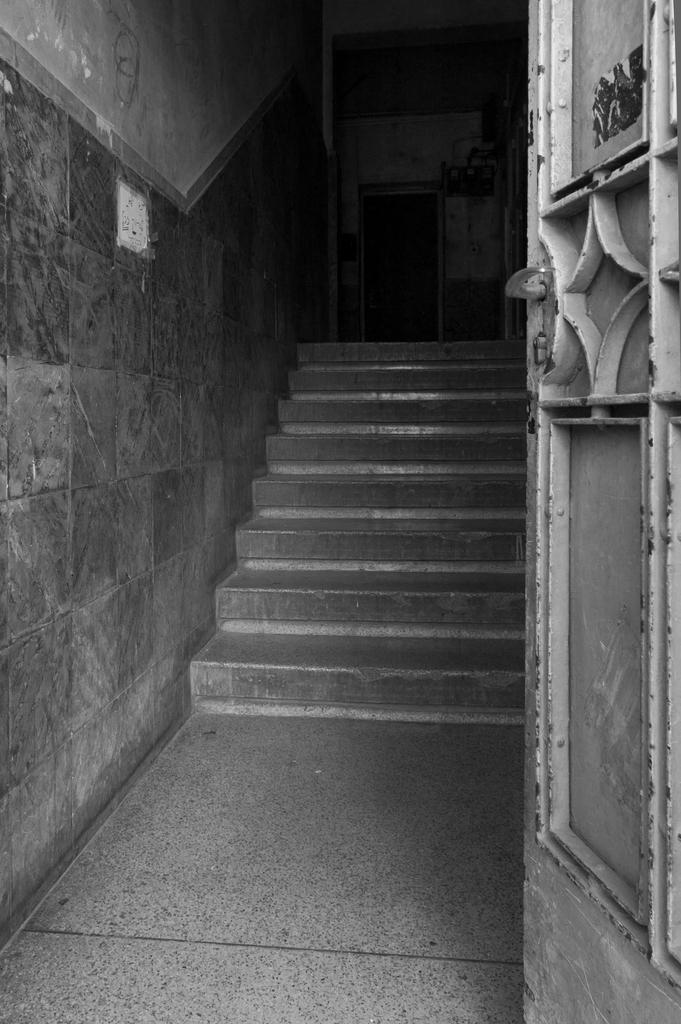What is the color scheme of the image? The image is black and white. What architectural feature can be seen in the image? There are stairs in the image. What other structures are present in the image? There is a wall and a door in the image. What type of table is visible in the image? There is no table present in the image. How does the faucet contribute to the overall design of the image? There is no faucet present in the image. 